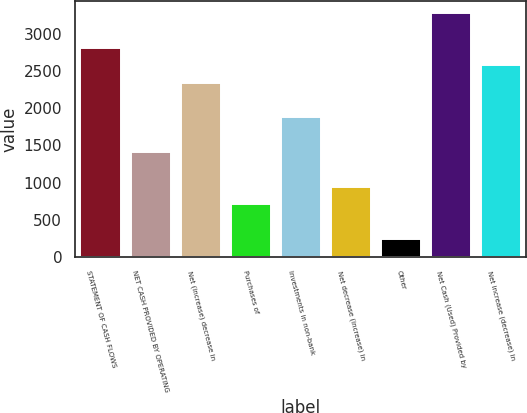<chart> <loc_0><loc_0><loc_500><loc_500><bar_chart><fcel>STATEMENT OF CASH FLOWS<fcel>NET CASH PROVIDED BY OPERATING<fcel>Net (increase) decrease in<fcel>Purchases of<fcel>Investments in non-bank<fcel>Net decrease (increase) in<fcel>Other<fcel>Net Cash (Used) Provided by<fcel>Net increase (decrease) in<nl><fcel>2809.8<fcel>1406.4<fcel>2342<fcel>704.7<fcel>1874.2<fcel>938.6<fcel>236.9<fcel>3277.6<fcel>2575.9<nl></chart> 